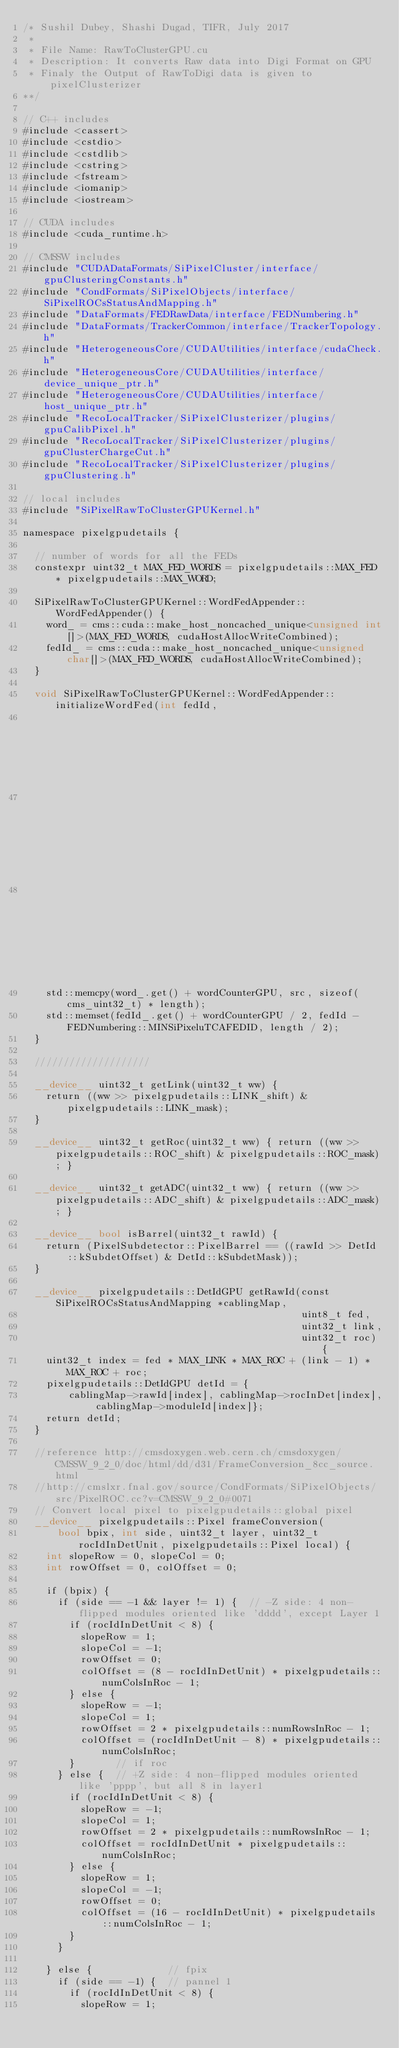<code> <loc_0><loc_0><loc_500><loc_500><_Cuda_>/* Sushil Dubey, Shashi Dugad, TIFR, July 2017
 *
 * File Name: RawToClusterGPU.cu
 * Description: It converts Raw data into Digi Format on GPU
 * Finaly the Output of RawToDigi data is given to pixelClusterizer
**/

// C++ includes
#include <cassert>
#include <cstdio>
#include <cstdlib>
#include <cstring>
#include <fstream>
#include <iomanip>
#include <iostream>

// CUDA includes
#include <cuda_runtime.h>

// CMSSW includes
#include "CUDADataFormats/SiPixelCluster/interface/gpuClusteringConstants.h"
#include "CondFormats/SiPixelObjects/interface/SiPixelROCsStatusAndMapping.h"
#include "DataFormats/FEDRawData/interface/FEDNumbering.h"
#include "DataFormats/TrackerCommon/interface/TrackerTopology.h"
#include "HeterogeneousCore/CUDAUtilities/interface/cudaCheck.h"
#include "HeterogeneousCore/CUDAUtilities/interface/device_unique_ptr.h"
#include "HeterogeneousCore/CUDAUtilities/interface/host_unique_ptr.h"
#include "RecoLocalTracker/SiPixelClusterizer/plugins/gpuCalibPixel.h"
#include "RecoLocalTracker/SiPixelClusterizer/plugins/gpuClusterChargeCut.h"
#include "RecoLocalTracker/SiPixelClusterizer/plugins/gpuClustering.h"

// local includes
#include "SiPixelRawToClusterGPUKernel.h"

namespace pixelgpudetails {

  // number of words for all the FEDs
  constexpr uint32_t MAX_FED_WORDS = pixelgpudetails::MAX_FED * pixelgpudetails::MAX_WORD;

  SiPixelRawToClusterGPUKernel::WordFedAppender::WordFedAppender() {
    word_ = cms::cuda::make_host_noncached_unique<unsigned int[]>(MAX_FED_WORDS, cudaHostAllocWriteCombined);
    fedId_ = cms::cuda::make_host_noncached_unique<unsigned char[]>(MAX_FED_WORDS, cudaHostAllocWriteCombined);
  }

  void SiPixelRawToClusterGPUKernel::WordFedAppender::initializeWordFed(int fedId,
                                                                        unsigned int wordCounterGPU,
                                                                        const cms_uint32_t *src,
                                                                        unsigned int length) {
    std::memcpy(word_.get() + wordCounterGPU, src, sizeof(cms_uint32_t) * length);
    std::memset(fedId_.get() + wordCounterGPU / 2, fedId - FEDNumbering::MINSiPixeluTCAFEDID, length / 2);
  }

  ////////////////////

  __device__ uint32_t getLink(uint32_t ww) {
    return ((ww >> pixelgpudetails::LINK_shift) & pixelgpudetails::LINK_mask);
  }

  __device__ uint32_t getRoc(uint32_t ww) { return ((ww >> pixelgpudetails::ROC_shift) & pixelgpudetails::ROC_mask); }

  __device__ uint32_t getADC(uint32_t ww) { return ((ww >> pixelgpudetails::ADC_shift) & pixelgpudetails::ADC_mask); }

  __device__ bool isBarrel(uint32_t rawId) {
    return (PixelSubdetector::PixelBarrel == ((rawId >> DetId::kSubdetOffset) & DetId::kSubdetMask));
  }

  __device__ pixelgpudetails::DetIdGPU getRawId(const SiPixelROCsStatusAndMapping *cablingMap,
                                                uint8_t fed,
                                                uint32_t link,
                                                uint32_t roc) {
    uint32_t index = fed * MAX_LINK * MAX_ROC + (link - 1) * MAX_ROC + roc;
    pixelgpudetails::DetIdGPU detId = {
        cablingMap->rawId[index], cablingMap->rocInDet[index], cablingMap->moduleId[index]};
    return detId;
  }

  //reference http://cmsdoxygen.web.cern.ch/cmsdoxygen/CMSSW_9_2_0/doc/html/dd/d31/FrameConversion_8cc_source.html
  //http://cmslxr.fnal.gov/source/CondFormats/SiPixelObjects/src/PixelROC.cc?v=CMSSW_9_2_0#0071
  // Convert local pixel to pixelgpudetails::global pixel
  __device__ pixelgpudetails::Pixel frameConversion(
      bool bpix, int side, uint32_t layer, uint32_t rocIdInDetUnit, pixelgpudetails::Pixel local) {
    int slopeRow = 0, slopeCol = 0;
    int rowOffset = 0, colOffset = 0;

    if (bpix) {
      if (side == -1 && layer != 1) {  // -Z side: 4 non-flipped modules oriented like 'dddd', except Layer 1
        if (rocIdInDetUnit < 8) {
          slopeRow = 1;
          slopeCol = -1;
          rowOffset = 0;
          colOffset = (8 - rocIdInDetUnit) * pixelgpudetails::numColsInRoc - 1;
        } else {
          slopeRow = -1;
          slopeCol = 1;
          rowOffset = 2 * pixelgpudetails::numRowsInRoc - 1;
          colOffset = (rocIdInDetUnit - 8) * pixelgpudetails::numColsInRoc;
        }       // if roc
      } else {  // +Z side: 4 non-flipped modules oriented like 'pppp', but all 8 in layer1
        if (rocIdInDetUnit < 8) {
          slopeRow = -1;
          slopeCol = 1;
          rowOffset = 2 * pixelgpudetails::numRowsInRoc - 1;
          colOffset = rocIdInDetUnit * pixelgpudetails::numColsInRoc;
        } else {
          slopeRow = 1;
          slopeCol = -1;
          rowOffset = 0;
          colOffset = (16 - rocIdInDetUnit) * pixelgpudetails::numColsInRoc - 1;
        }
      }

    } else {             // fpix
      if (side == -1) {  // pannel 1
        if (rocIdInDetUnit < 8) {
          slopeRow = 1;</code> 